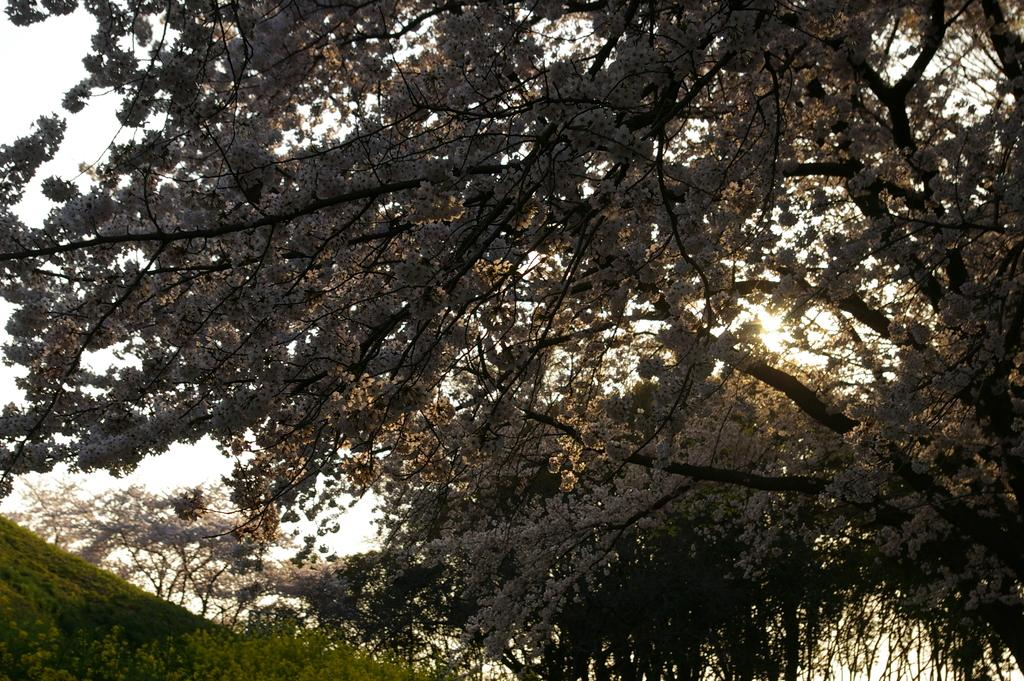What type of vegetation can be seen in the image? There are trees, flowers, and plants in the image. What part of the natural environment is visible in the image? The sky is visible in the image. What type of terrain is present in the image? There is a hill in the image. How are the snails distributed in the image? There are no snails present in the image, so their distribution cannot be determined. 